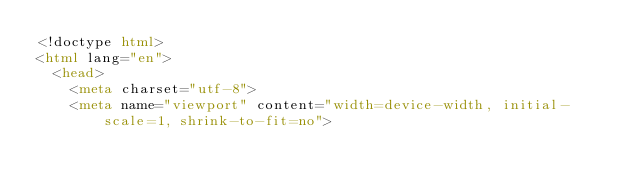<code> <loc_0><loc_0><loc_500><loc_500><_HTML_><!doctype html>
<html lang="en">
  <head>
    <meta charset="utf-8">
    <meta name="viewport" content="width=device-width, initial-scale=1, shrink-to-fit=no"></code> 